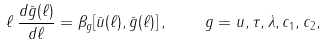Convert formula to latex. <formula><loc_0><loc_0><loc_500><loc_500>\ell \, \frac { d \bar { g } ( \ell ) } { d \ell } = \beta _ { g } [ \bar { u } ( \ell ) , \bar { g } ( \ell ) ] \, , \quad g = u , \tau , \lambda , c _ { 1 } , c _ { 2 } ,</formula> 